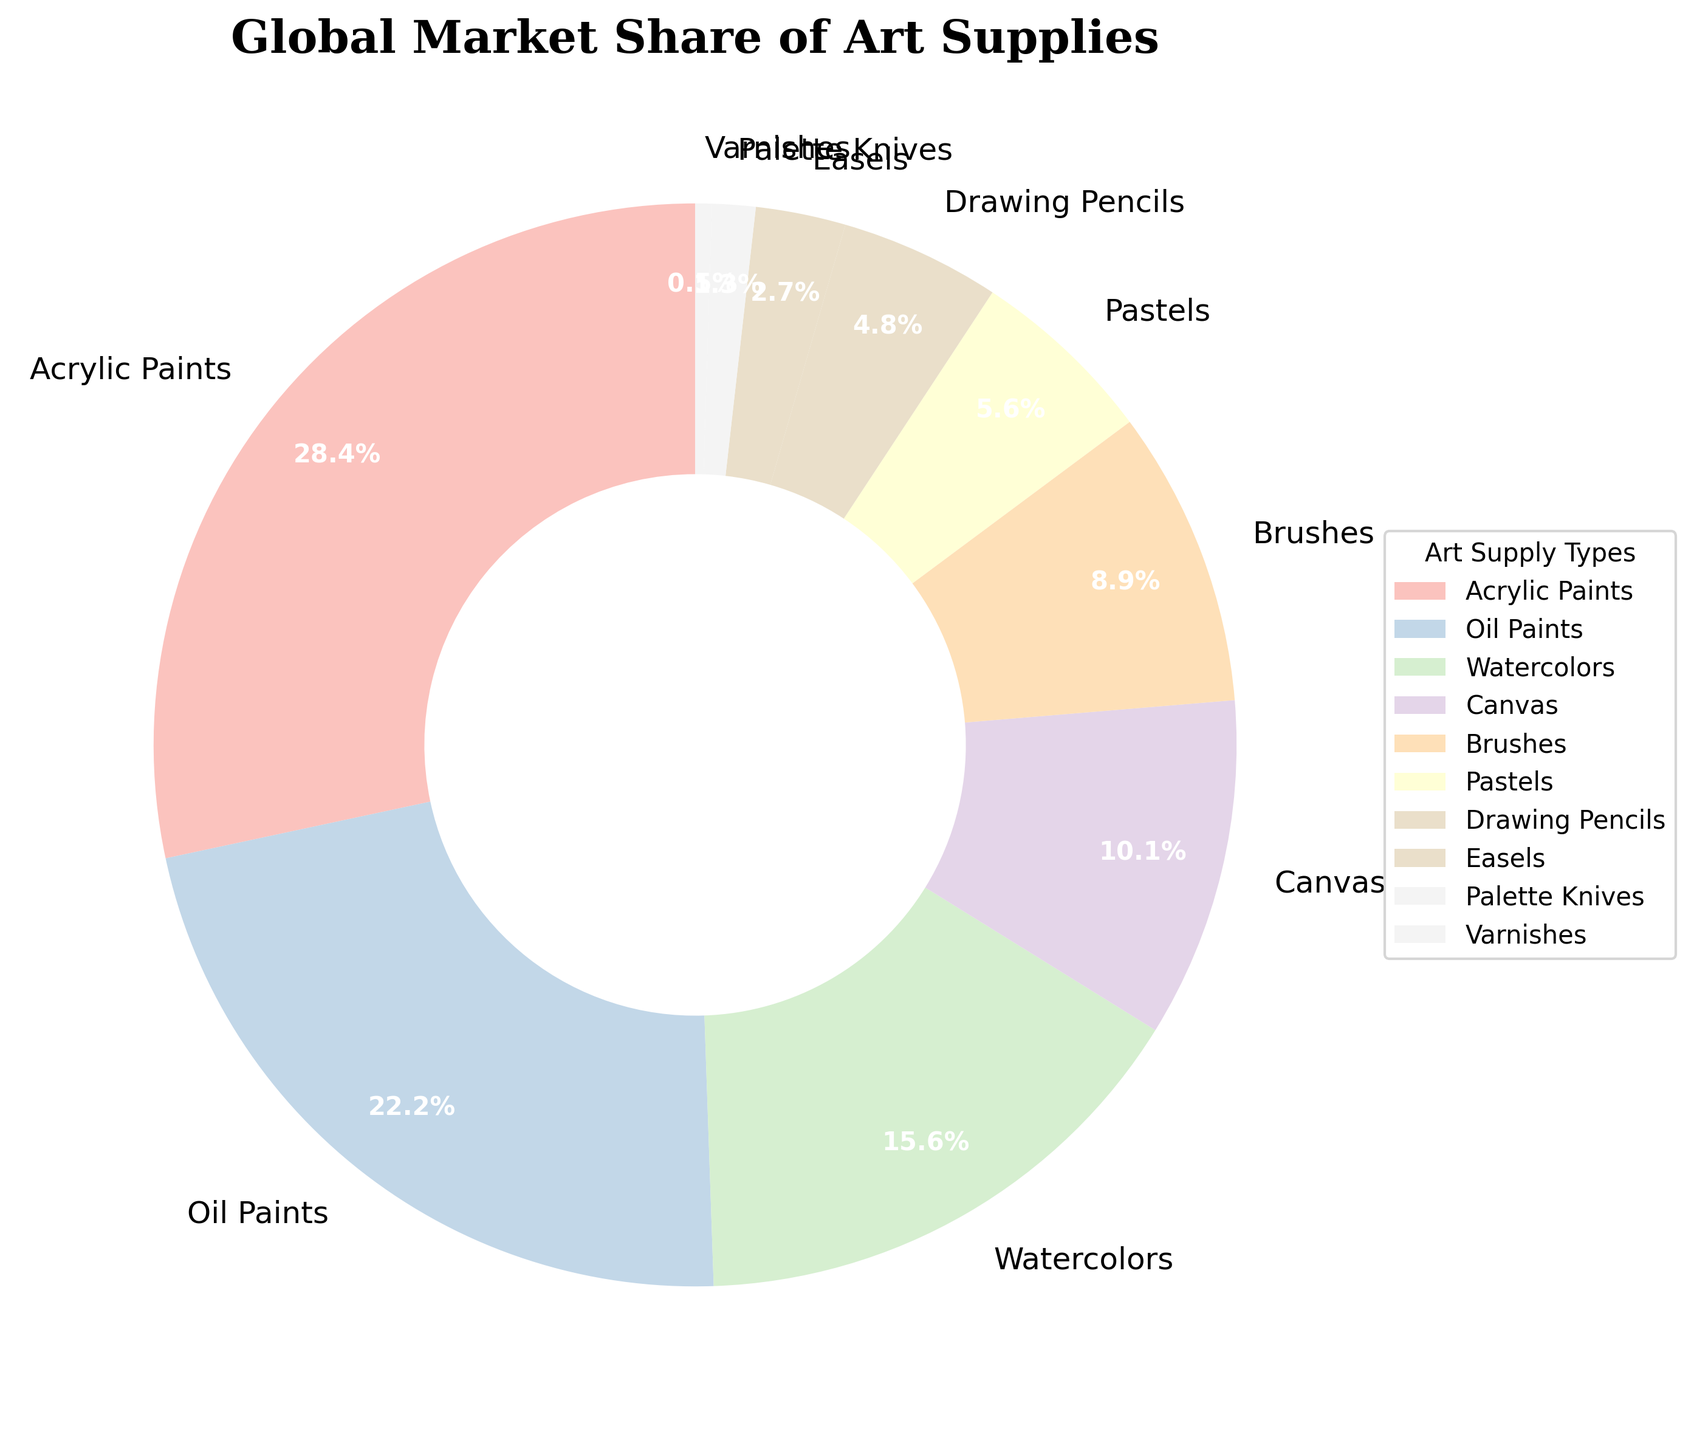What type of art supply holds the largest market share? The pie chart shows the percentage of the market share for each art supply type. Acrylic Paints occupy the largest segment with 28.5%.
Answer: Acrylic Paints Which two art supplies have the closest market share percentages? Observing the pie chart, Oil Paints and Watercolors have market shares of 22.3% and 15.7%, respectively. None of the other pairs are as close.
Answer: Oil Paints and Watercolors How does the market share of Brushes compare to that of Pastels? From the pie chart, we see that Brushes have a market share of 8.9% and Pastels have a market share of 5.6%. Brushes have a larger market share by 3.3%.
Answer: Brushes have a larger market share What is the combined market share of Canvas and Brushes? Adding the market shares of Canvas (10.2%) and Brushes (8.9%), we get a total of 19.1%.
Answer: 19.1% Which art supply has the smallest market share and what is its percentage? The pie chart indicates that Varnishes have the smallest market share, which is 0.5%.
Answer: Varnishes, 0.5% Are there more art supplies with a market share greater than 10% or less than 10%? The pie chart shows four art supplies with market shares over 10%: Acrylic Paints, Oil Paints, Watercolors, and Canvas. The other six supplies have shares under 10%. Hence, there are more with shares less than 10%.
Answer: Less than 10% If the market share of Drawing Pencils were to increase by 1.2%, how would it compare to the market share of Brushes? Drawing Pencils currently hold 4.8%. An increase of 1.2% would make it 6.0%. Brushes have an 8.9% market share, which would still be higher.
Answer: Brushes would still have a higher market share Which segment's color indicates it holds a larger share: Watercolors or Easels? Analyzing the pie chart, Watercolors have a much larger segment compared to Easels, which visually represents their higher market share (15.7% vs. 2.7%).
Answer: Watercolors What proportion of the market is held by art supplies used for painting (Acrylic Paints, Oil Paints, Watercolors)? Adding up their shares: Acrylic Paints (28.5%), Oil Paints (22.3%), and Watercolors (15.7%), we get a total of 66.5%.
Answer: 66.5% If we were to combine the market shares of the smallest three art supplies, would it be larger than the share of Canvas alone? The three smallest shares are Varnishes (0.5%), Palette Knives (1.3%), and Easels (2.7%). Adding these, we get 0.5% + 1.3% + 2.7% = 4.5%. Canvas alone has 10.2%, which is larger than 4.5%.
Answer: No, Canvas alone is larger 